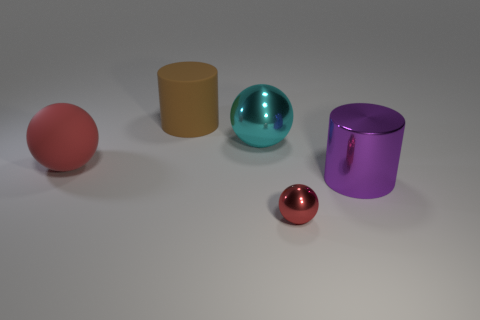How many large rubber objects have the same color as the tiny object?
Make the answer very short. 1. What number of other things are there of the same shape as the big cyan metallic object?
Keep it short and to the point. 2. Is the big cyan object made of the same material as the big red ball?
Your answer should be very brief. No. What material is the ball that is both right of the big brown object and in front of the big cyan thing?
Your answer should be compact. Metal. The big rubber object that is to the left of the matte cylinder is what color?
Offer a terse response. Red. Is the number of large balls to the left of the purple cylinder greater than the number of purple metallic cylinders?
Provide a short and direct response. Yes. How many other things are there of the same size as the red metallic object?
Offer a terse response. 0. There is a small red metal thing; what number of large cyan spheres are left of it?
Offer a very short reply. 1. Are there the same number of tiny red things that are on the right side of the large cyan metal ball and brown cylinders in front of the big purple metallic thing?
Provide a succinct answer. No. What size is the other metal thing that is the same shape as the cyan shiny object?
Make the answer very short. Small. 